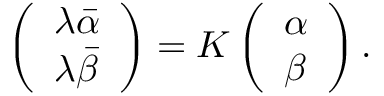<formula> <loc_0><loc_0><loc_500><loc_500>\left ( \begin{array} { l } { { \lambda \bar { \alpha } } } \\ { { \lambda \bar { \beta } } } \end{array} \right ) = K \left ( \begin{array} { l } { \alpha } \\ { \beta } \end{array} \right ) .</formula> 